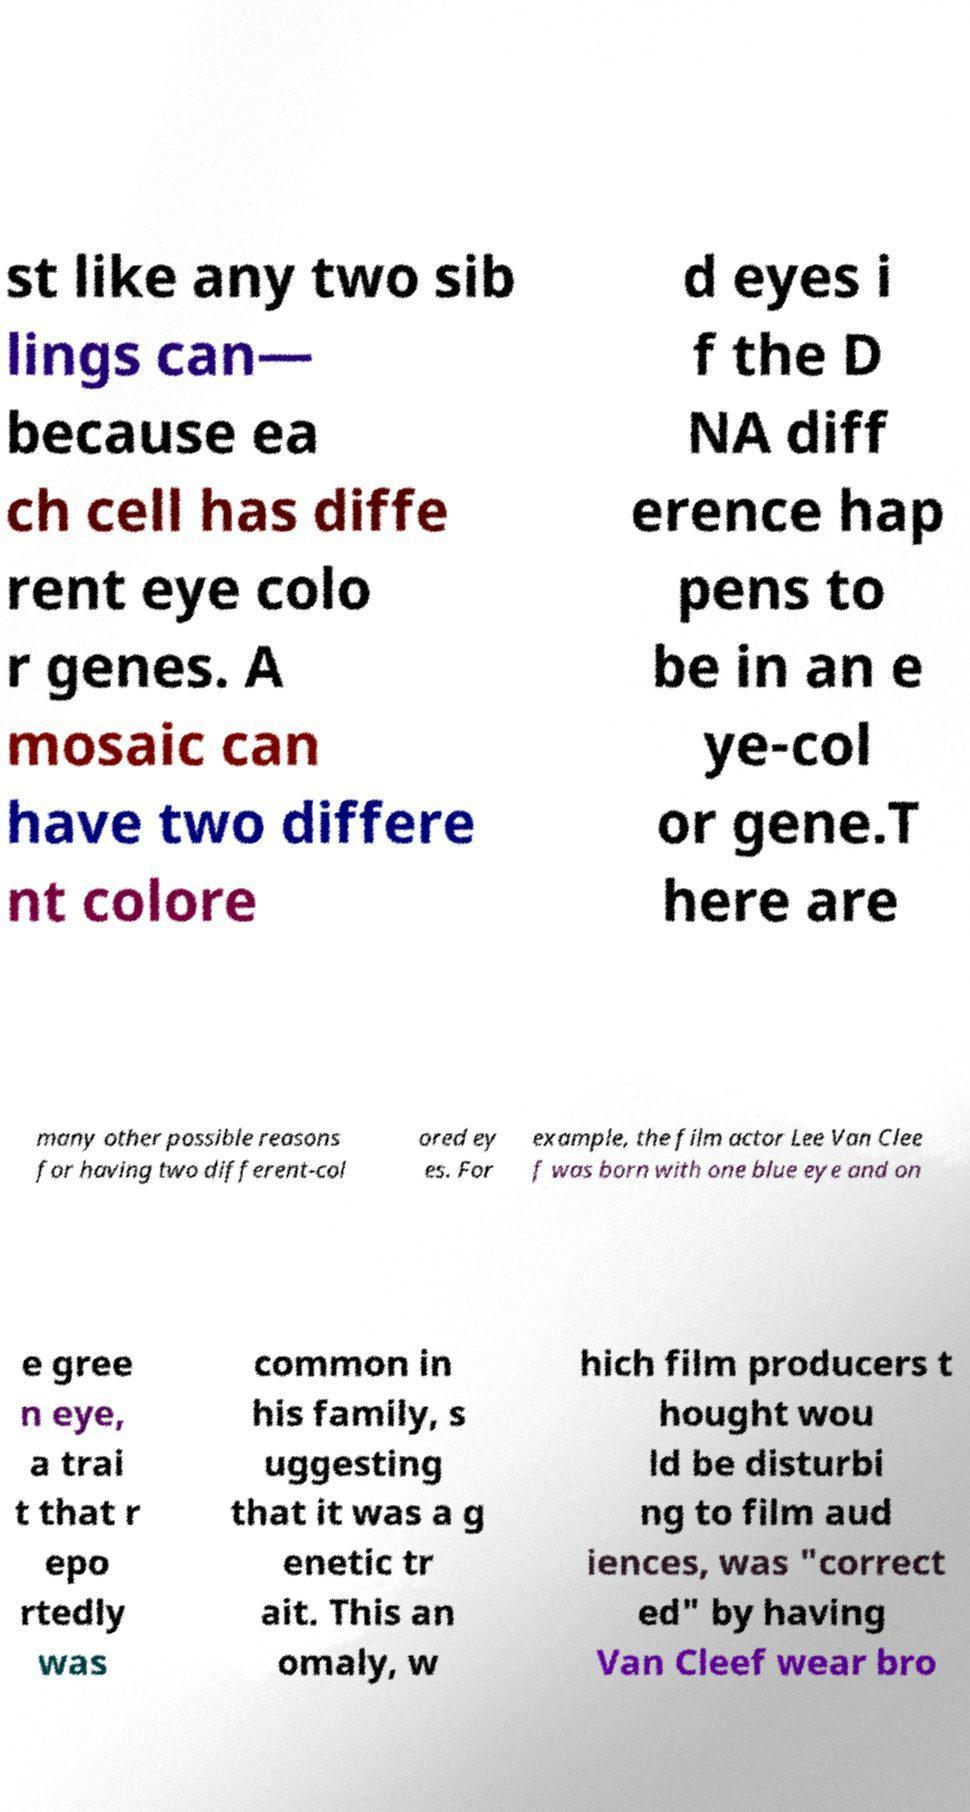I need the written content from this picture converted into text. Can you do that? st like any two sib lings can— because ea ch cell has diffe rent eye colo r genes. A mosaic can have two differe nt colore d eyes i f the D NA diff erence hap pens to be in an e ye-col or gene.T here are many other possible reasons for having two different-col ored ey es. For example, the film actor Lee Van Clee f was born with one blue eye and on e gree n eye, a trai t that r epo rtedly was common in his family, s uggesting that it was a g enetic tr ait. This an omaly, w hich film producers t hought wou ld be disturbi ng to film aud iences, was "correct ed" by having Van Cleef wear bro 